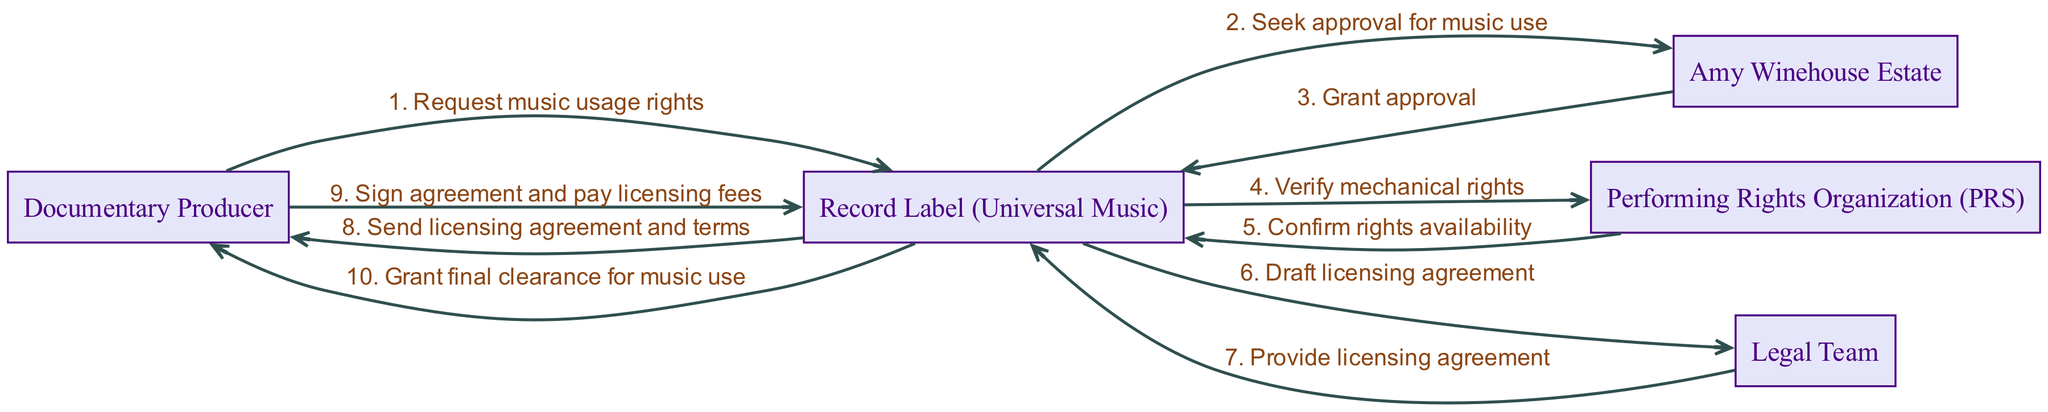What is the first action taken by the Documentary Producer? The first action taken by the Documentary Producer in the sequence diagram is to request music usage rights from the Record Label (Universal Music).
Answer: Request music usage rights How many actors are involved in the copyright clearance procedure? The diagram lists five actors involved in the procedure: Documentary Producer, Record Label (Universal Music), Amy Winehouse Estate, Performing Rights Organization (PRS), and Legal Team.
Answer: Five Who does the Record Label seek approval from? The Record Label (Universal Music) seeks approval for music use from the Amy Winehouse Estate according to the sequence shown in the diagram.
Answer: Amy Winehouse Estate What is the last step in the process? The final step in the procedure, as depicted in the diagram, is that the Record Label (Universal Music) grants final clearance for music use to the Documentary Producer.
Answer: Grant final clearance for music use How many messages are exchanged between the Documentary Producer and the Record Label? There are two messages exchanged between the Documentary Producer and the Record Label: the initial request for music usage rights and later signing the agreement and paying licensing fees.
Answer: Two What does the Legal Team provide to the Record Label? The Legal Team is responsible for providing the licensing agreement to the Record Label (Universal Music) as part of the process in the diagram.
Answer: Provide licensing agreement Which organization verifies the mechanical rights for the music? The Performing Rights Organization (PRS) is the organization that verifies the mechanical rights for the music in the flow of the sequence depicted.
Answer: Performing Rights Organization (PRS) What type of rights does the Performing Rights Organization confirm? The Performing Rights Organization confirms mechanical rights availability in the sequence shown in the diagram.
Answer: Mechanical rights availability 